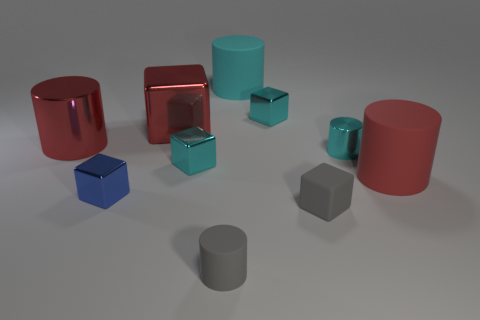What number of other cubes have the same size as the blue shiny cube?
Your answer should be compact. 3. Is the number of big red metal things behind the small cyan metallic cylinder less than the number of rubber cylinders?
Give a very brief answer. Yes. How many red things are to the right of the tiny gray matte block?
Ensure brevity in your answer.  1. There is a metallic cylinder behind the tiny metal cylinder that is in front of the small block that is behind the big red metallic cylinder; what is its size?
Your answer should be very brief. Large. There is a large red matte object; is its shape the same as the small rubber object right of the large cyan cylinder?
Offer a terse response. No. The red cylinder that is the same material as the small blue object is what size?
Make the answer very short. Large. Is there anything else of the same color as the big cube?
Give a very brief answer. Yes. There is a cylinder that is in front of the big matte cylinder in front of the large rubber object left of the red matte cylinder; what is it made of?
Your answer should be compact. Rubber. What number of rubber objects are big red things or small blue blocks?
Ensure brevity in your answer.  1. Is the color of the big shiny cube the same as the large metallic cylinder?
Your response must be concise. Yes. 